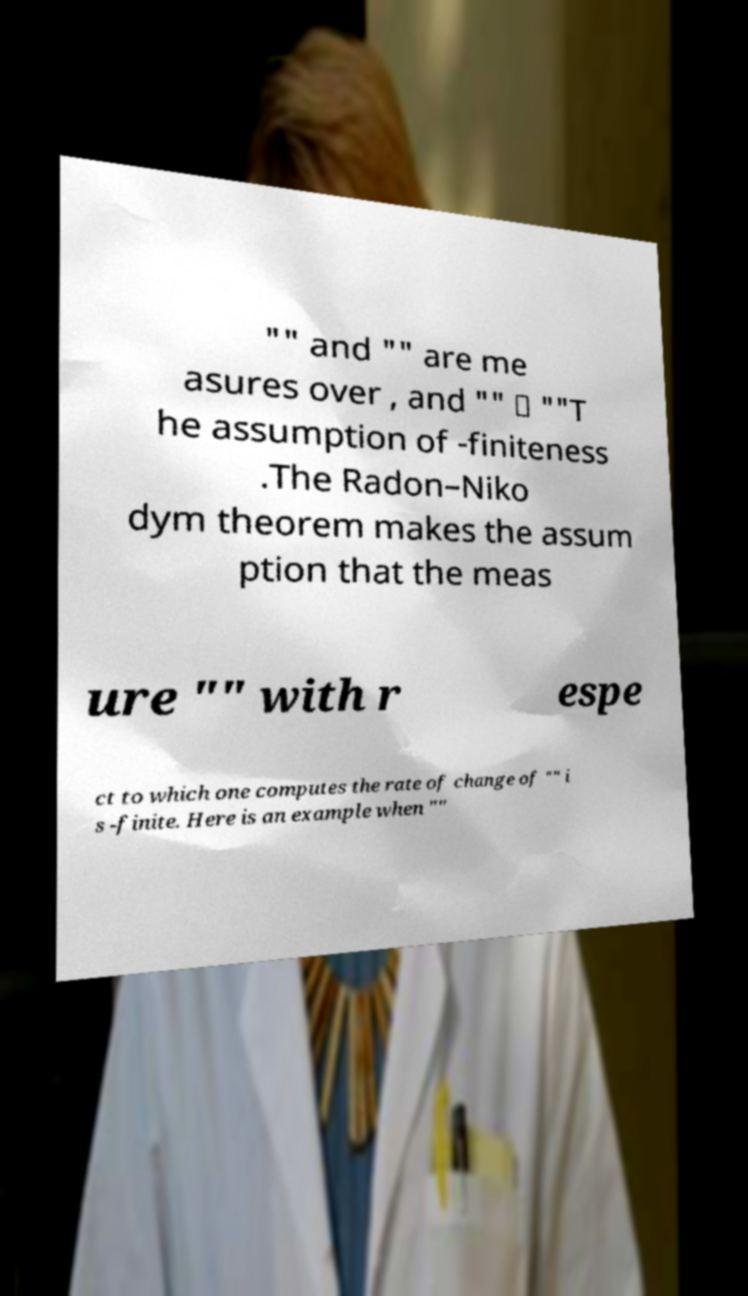Can you accurately transcribe the text from the provided image for me? "" and "" are me asures over , and "" ≪ ""T he assumption of -finiteness .The Radon–Niko dym theorem makes the assum ption that the meas ure "" with r espe ct to which one computes the rate of change of "" i s -finite. Here is an example when "" 